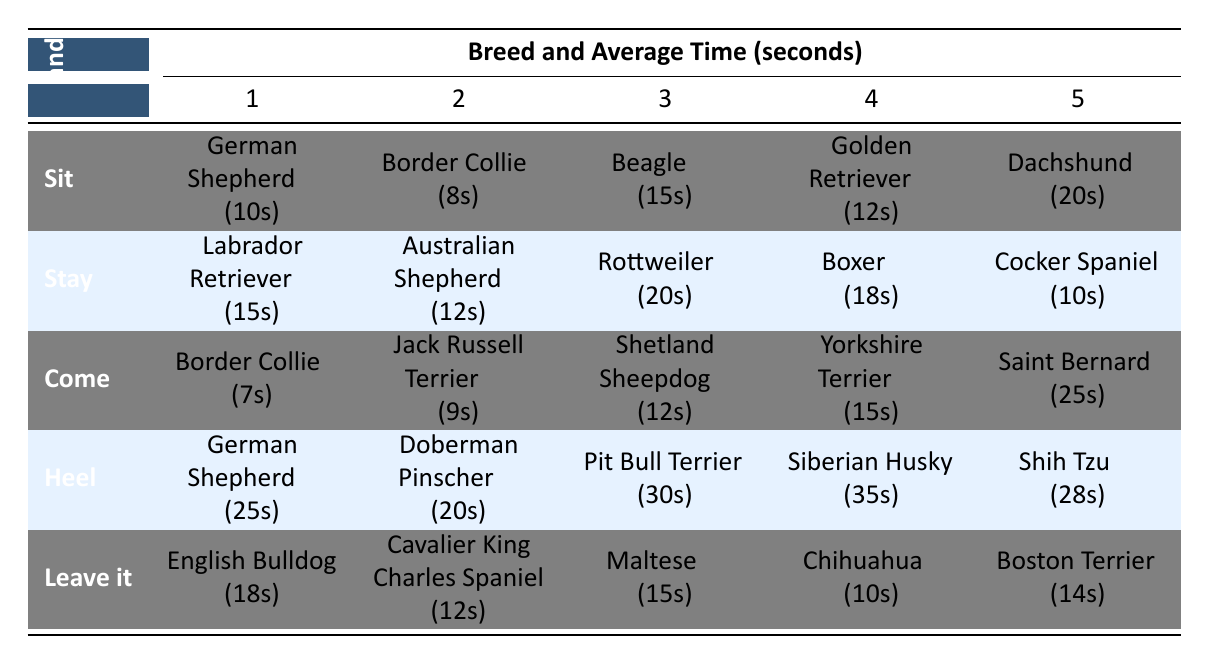What is the average time taken to teach the 'Sit' command to a Golden Retriever? The average time taken to teach the 'Sit' command to a Golden Retriever is listed directly in the table as 12 seconds.
Answer: 12 seconds Which breed takes the longest time to learn the 'Come' command? According to the table, the breed that takes the longest to learn the 'Come' command is the Saint Bernard with an average time of 25 seconds.
Answer: Saint Bernard What is the difference in average training time between teaching 'Heel' to a German Shepherd and a Doberman Pinscher? The table shows that it takes 25 seconds for a German Shepherd and 20 seconds for a Doberman Pinscher to learn the 'Heel' command. The difference is 25 - 20 = 5 seconds.
Answer: 5 seconds Is it true that a Chihuahua takes the least time to learn the 'Leave it' command? The table indicates that the Chihuahua takes 10 seconds to learn the 'Leave it' command, which is less than the other listed breeds for that command. Therefore, the statement is true.
Answer: Yes What is the average time taken to teach the 'Stay' command across all breeds listed? To find the average, we first sum the average times: 15 + 12 + 20 + 18 + 10 = 85 seconds. There are 5 breeds, so the average time is 85 / 5 = 17 seconds.
Answer: 17 seconds Which command takes the most time for a Siberian Husky to learn? By examining the table, the 'Heel' command requires 35 seconds for a Siberian Husky, which is the longest in comparison to other commands in the table.
Answer: Heel How many breeds take 15 seconds or less to learn the 'Sit' command? The table shows that two breeds, Border Collie (8 seconds) and German Shepherd (10 seconds), take 15 seconds or less to learn the 'Sit' command.
Answer: 2 breeds What is the average time taken to teach all commands across all breeds? To calculate the overall average, we total the average times for each command and breed: (10+8+15+12+20) + (15+12+20+18+10) + (7+9+12+15+25) + (25+20+30+35+28) + (18+12+15+10+14) = 382 seconds. There are 5 commands with 5 breeds each, resulting in 25 data points, so the average time is 382 / 25 = 15.28 seconds.
Answer: 15.28 seconds 